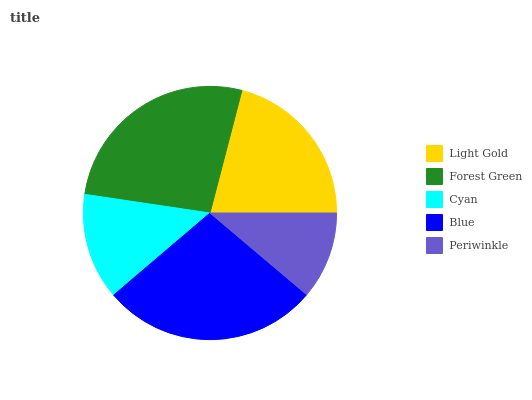Is Periwinkle the minimum?
Answer yes or no. Yes. Is Blue the maximum?
Answer yes or no. Yes. Is Forest Green the minimum?
Answer yes or no. No. Is Forest Green the maximum?
Answer yes or no. No. Is Forest Green greater than Light Gold?
Answer yes or no. Yes. Is Light Gold less than Forest Green?
Answer yes or no. Yes. Is Light Gold greater than Forest Green?
Answer yes or no. No. Is Forest Green less than Light Gold?
Answer yes or no. No. Is Light Gold the high median?
Answer yes or no. Yes. Is Light Gold the low median?
Answer yes or no. Yes. Is Blue the high median?
Answer yes or no. No. Is Cyan the low median?
Answer yes or no. No. 